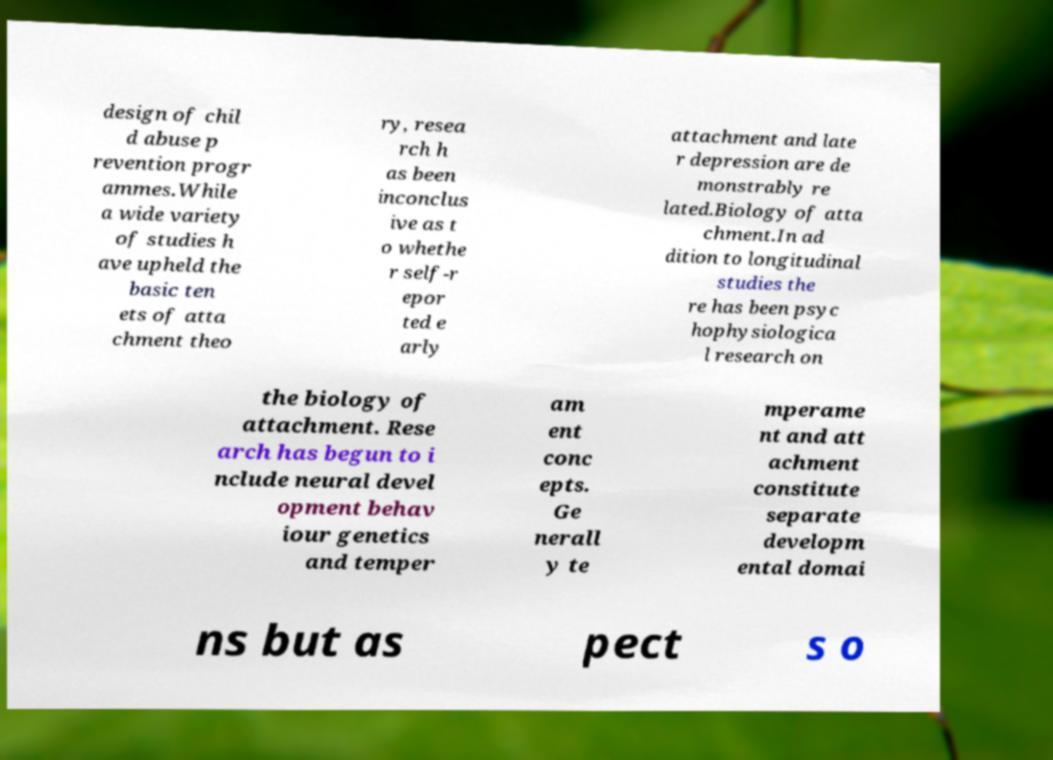I need the written content from this picture converted into text. Can you do that? design of chil d abuse p revention progr ammes.While a wide variety of studies h ave upheld the basic ten ets of atta chment theo ry, resea rch h as been inconclus ive as t o whethe r self-r epor ted e arly attachment and late r depression are de monstrably re lated.Biology of atta chment.In ad dition to longitudinal studies the re has been psyc hophysiologica l research on the biology of attachment. Rese arch has begun to i nclude neural devel opment behav iour genetics and temper am ent conc epts. Ge nerall y te mperame nt and att achment constitute separate developm ental domai ns but as pect s o 